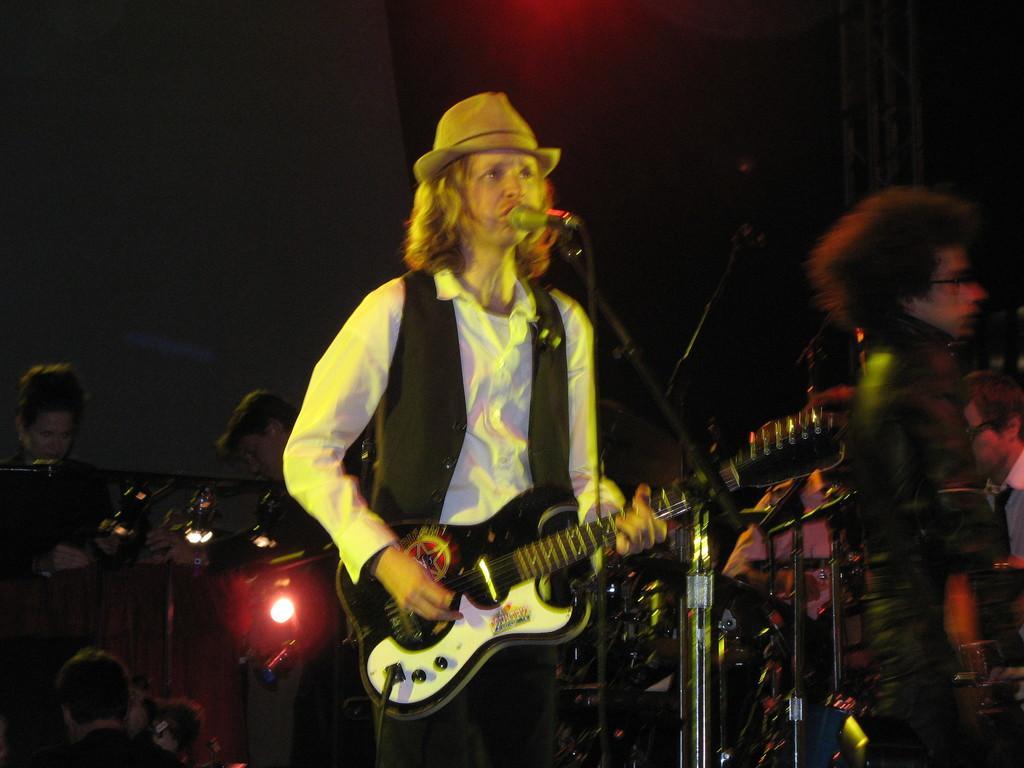Please provide a concise description of this image. As we can see in the image there are few persons. The person standing in the front is singing on mike and holding guitar in his hand. 